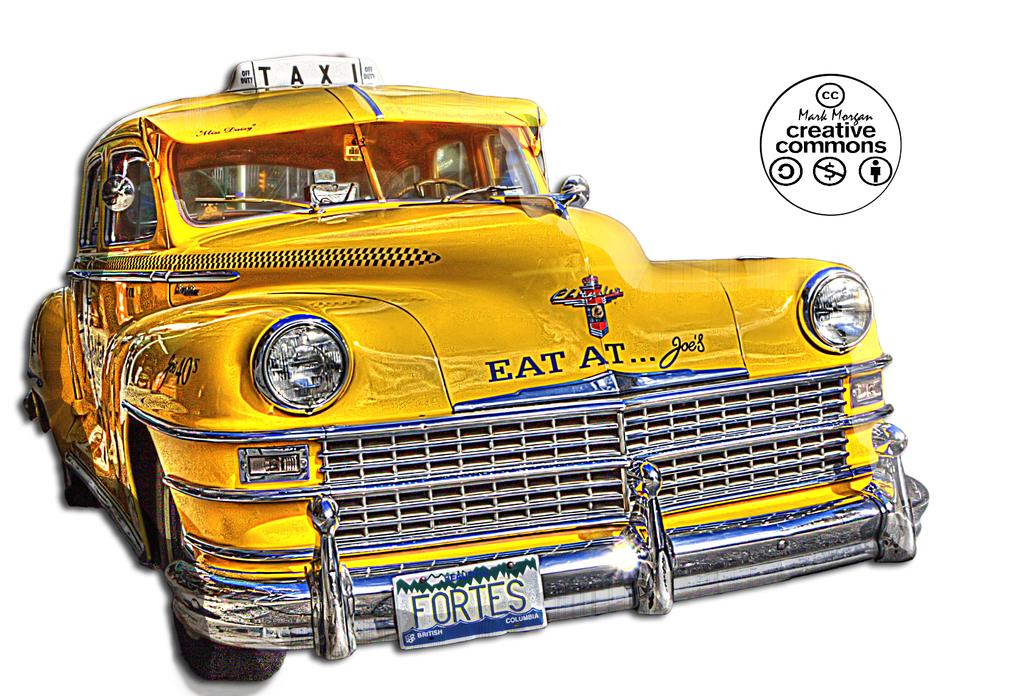<image>
Relay a brief, clear account of the picture shown. a taxi cab that says fortes on the front 